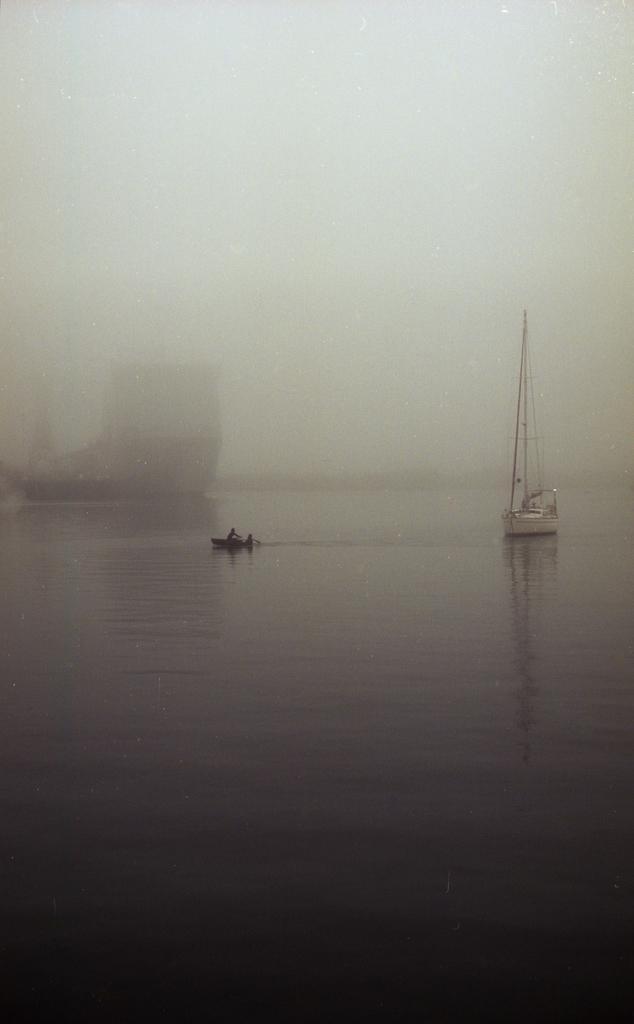Describe this image in one or two sentences. In this picture I can see few boats in the water and looks like fog and I can see couple of them seated on a boat. 